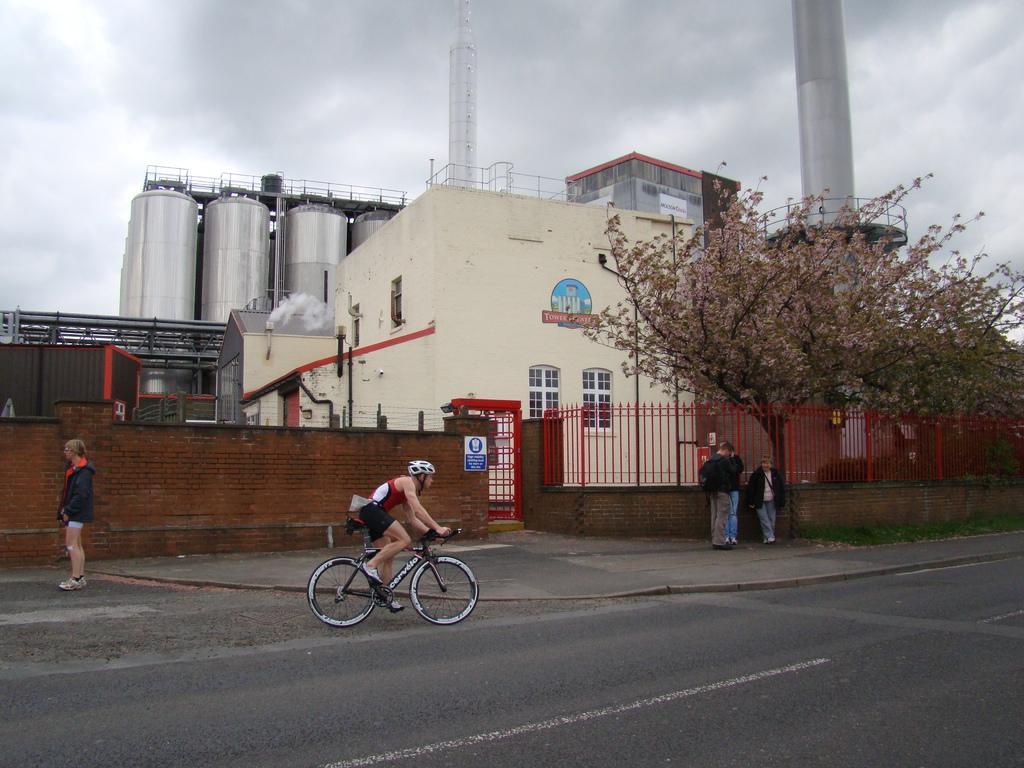Please provide a concise description of this image. In this picture we can see a person is riding a bicycle on the road and some other people are standing. Behind the people, there are iron grilles, wall, trees, buildings and some other objects. At the top of the image, there is the cloudy sky. 